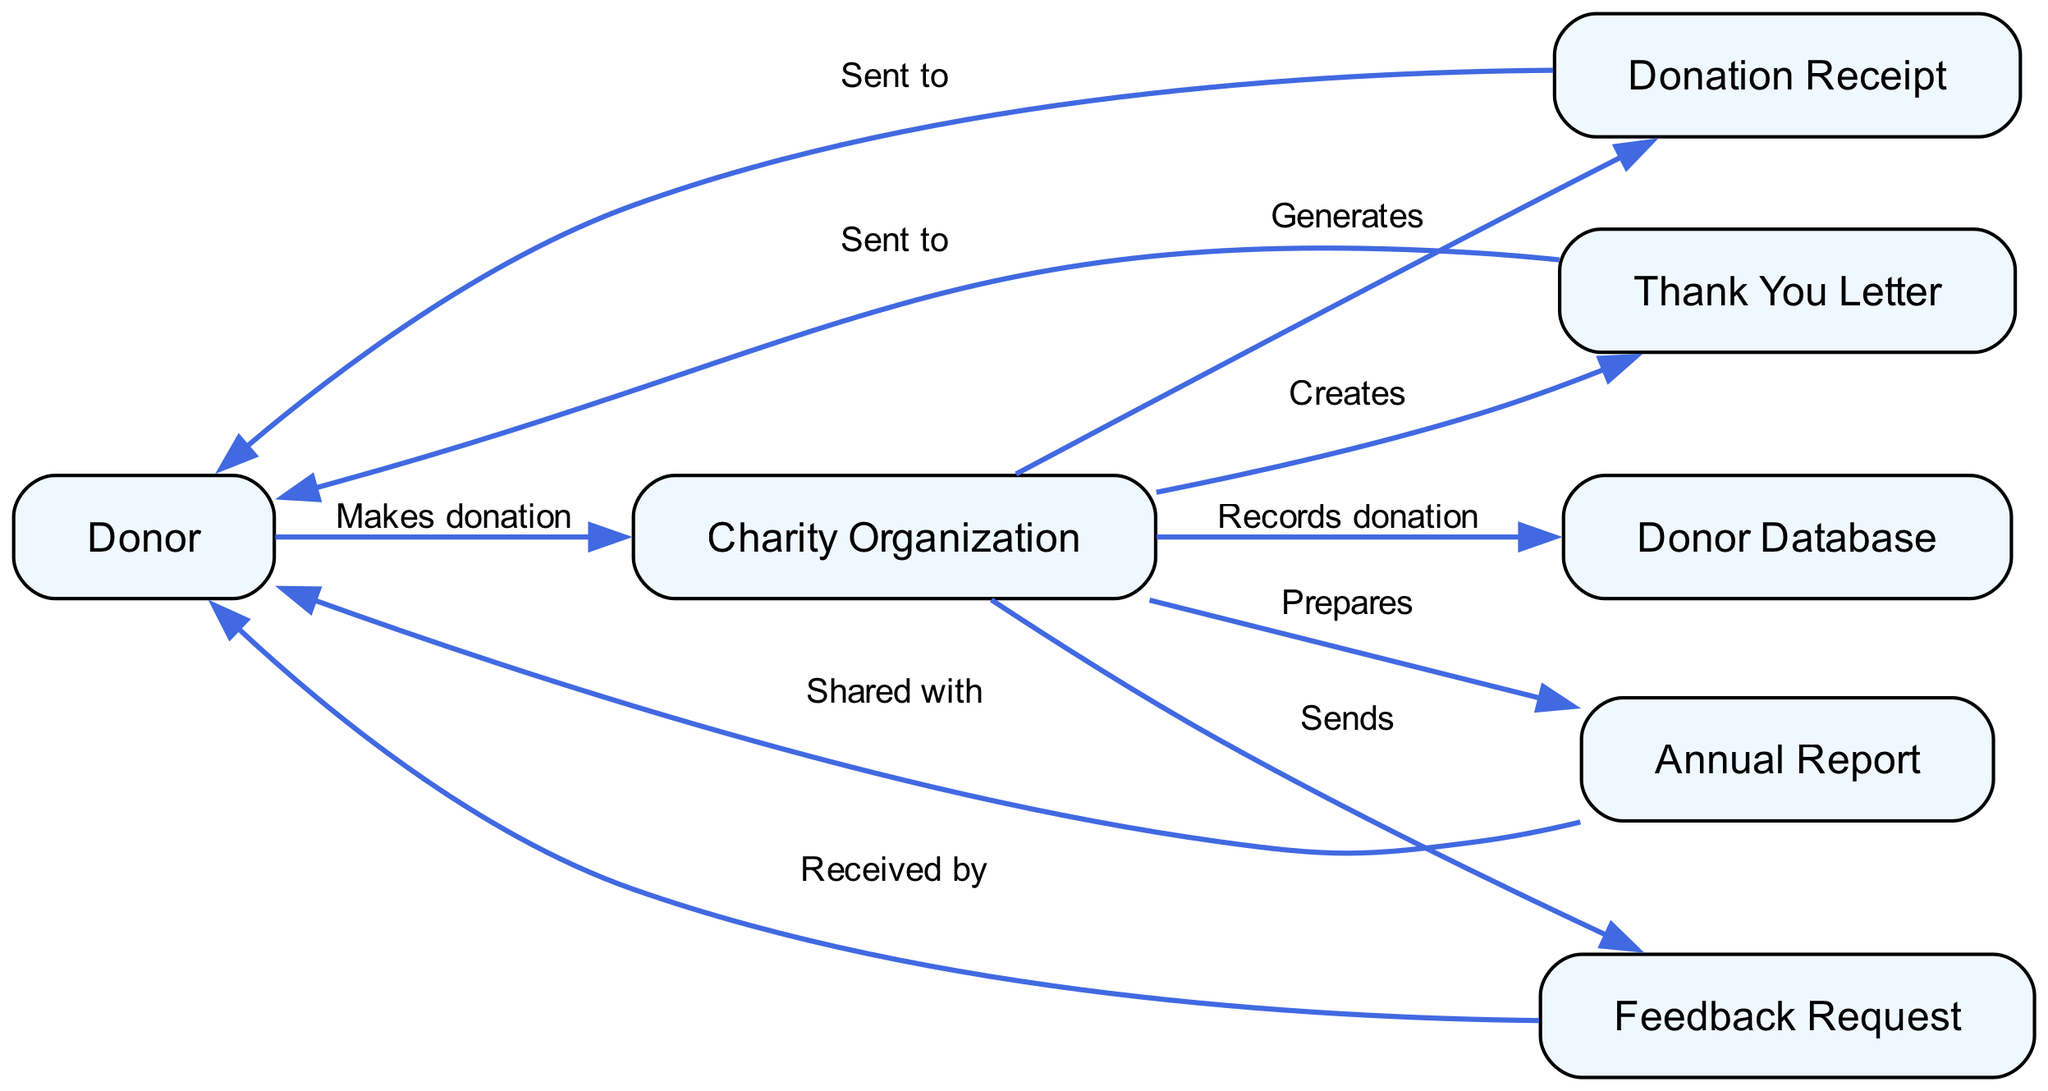What are the roles involved in the acknowledgment process? The roles involved in the acknowledgment process are listed as elements in the diagram: Donor, Charity Organization, Donation Receipt, Thank You Letter, Donor Database, Annual Report, and Feedback Request.
Answer: Donor, Charity Organization, Donation Receipt, Thank You Letter, Donor Database, Annual Report, Feedback Request How many interactions are depicted in the diagram? The interactions are represented by the edges connecting the nodes. Upon counting, there are a total of ten interactions depicted in the diagram.
Answer: Ten What does the donor receive after making a donation? The diagram shows that the donor receives a Donation Receipt and a Thank You Letter after the donation is made.
Answer: Donation Receipt, Thank You Letter Which entity records the donation in the donor database? The Charity Organization is responsible for recording the donation in the Donor Database as indicated by the direct interaction shown in the diagram.
Answer: Charity Organization What is the final step in the acknowledgment process? The final step in the acknowledgment process involves the Charity Organization sending a Feedback Request, as shown by the last interaction in the diagram.
Answer: Sends Feedback Request What type of document highlights the charity's achievements? The Annual Report is a publication that highlights the charity's achievements and the usage of funds, as indicated in the diagram's sequence.
Answer: Annual Report How does the charity express gratitude to the donor? The charity expresses gratitude by sending a Thank You Letter to the donor as illustrated in the sequence of interactions in the diagram.
Answer: Thank You Letter What step follows the creation of the Thank You Letter? The step that follows the creation of the Thank You Letter is sending it to the donor, as shown in the sequence of interactions.
Answer: Sent to Donor 